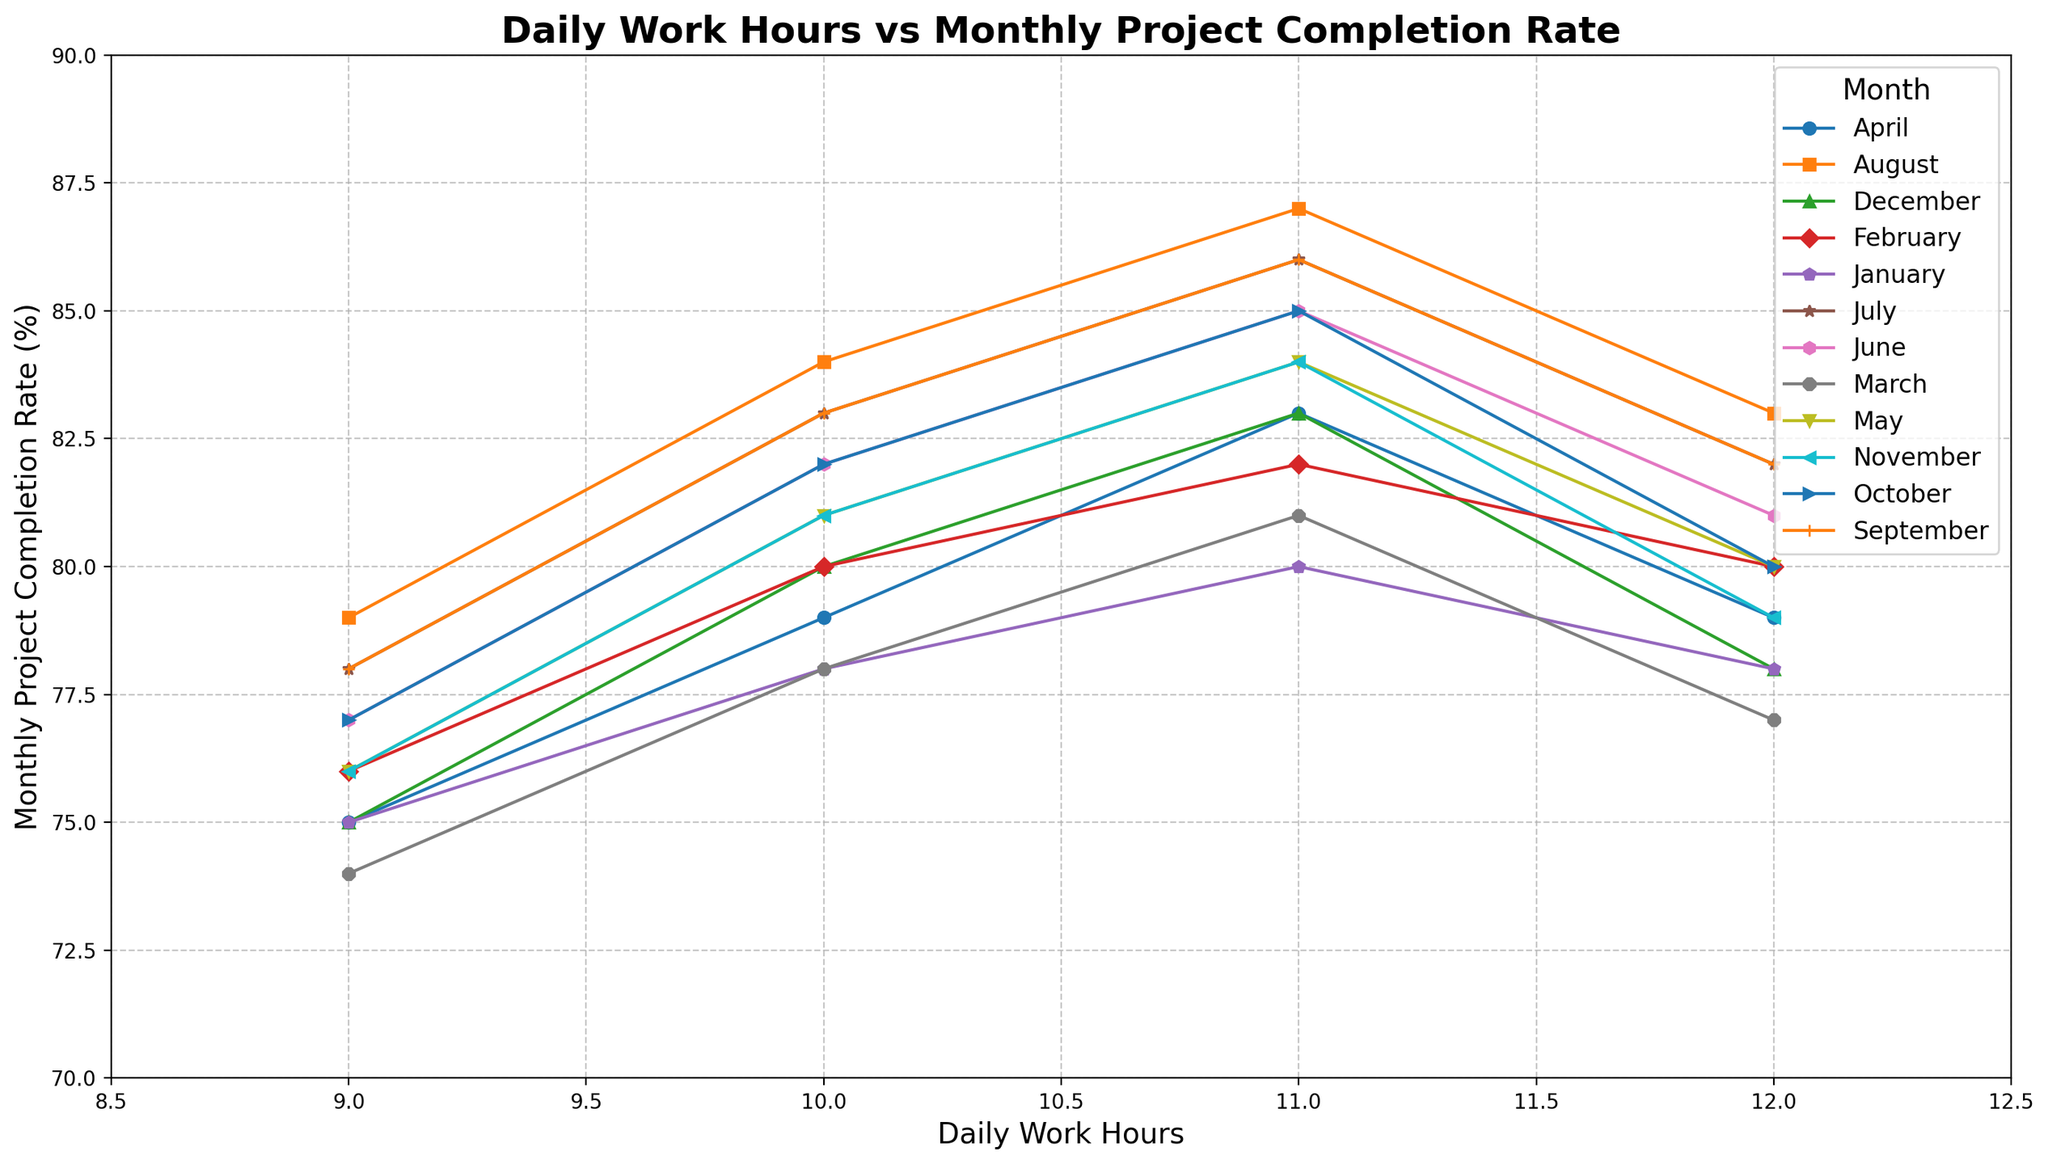What is the trend in Monthly Project Completion Rate as Daily Work Hours increase from 9 to 12 in July? The line for July shows a consistent upward trend, starting at 78% for 9 hours per day and reaching 82% for 12 hours per day.
Answer: Upward Trend In which month does the Monthly Project Completion Rate seem to be the highest at 10 Daily Work Hours? From visual inspection, the line for August peaks the highest at 10 Daily Work Hours compared to other months, hitting 84%.
Answer: August Compare the Monthly Project Completion Rate between 11 and 12 Daily Work Hours across all months. Which month shows the biggest decline? For each month, I compare values at 11 and 12 Daily Work Hours. The biggest decline is noticeable in March, where the rate drops from 81% to 77%, a 4% difference.
Answer: March What is the average Monthly Project Completion Rate for September across all Daily Work Hours? Adding the values from September (78%, 83%, 86%, 82%) and dividing by 4, the average is (78+83+86+82)/4 = 82.25%.
Answer: 82.25% At 9 Daily Work Hours, which month shows the lowest Monthly Project Completion Rate? From the plot, the lowest rate at 9 daily hours is observed in March at 74%.
Answer: March How does the Monthly Project Completion Rate change from January to December at 12 Daily Work Hours? The completion rate starts at 78% in January, oscillates slightly but follows a downward trend reaching 78% again in December, showing an overall consistent if slightly variable trend.
Answer: Consistent Which month shows the smallest difference between the highest and lowest Monthly Project Completion Rates across all Daily Work Hours? By visually comparing the height difference of data points for each month, December shows the smallest difference (75% to 83%), a range of 8%.
Answer: December What pattern do you observe in the Monthly Project Completion Rates for March and April when daily work hours increase from 9 to 12? Both March and April lines initially rise and then slightly decline. March: (74% to 78%), April: (75% to 79%).
Answer: Rise and slight decline How does the rate of increase of Monthly Project Completion Rate from 9 to 11 Daily Work Hours compare between June and August? In June, the rate increases from 77% to 85% (8%). In August, it increases from 79% to 87% (8%). Both months show an equal increase.
Answer: Equal increase Which month has the highest variance in Monthly Project Completion Rate as Daily Work Hours increase? By estimating the spread of data points, July exhibits the highest variance with rates ranging from 78% to 86%.
Answer: July 